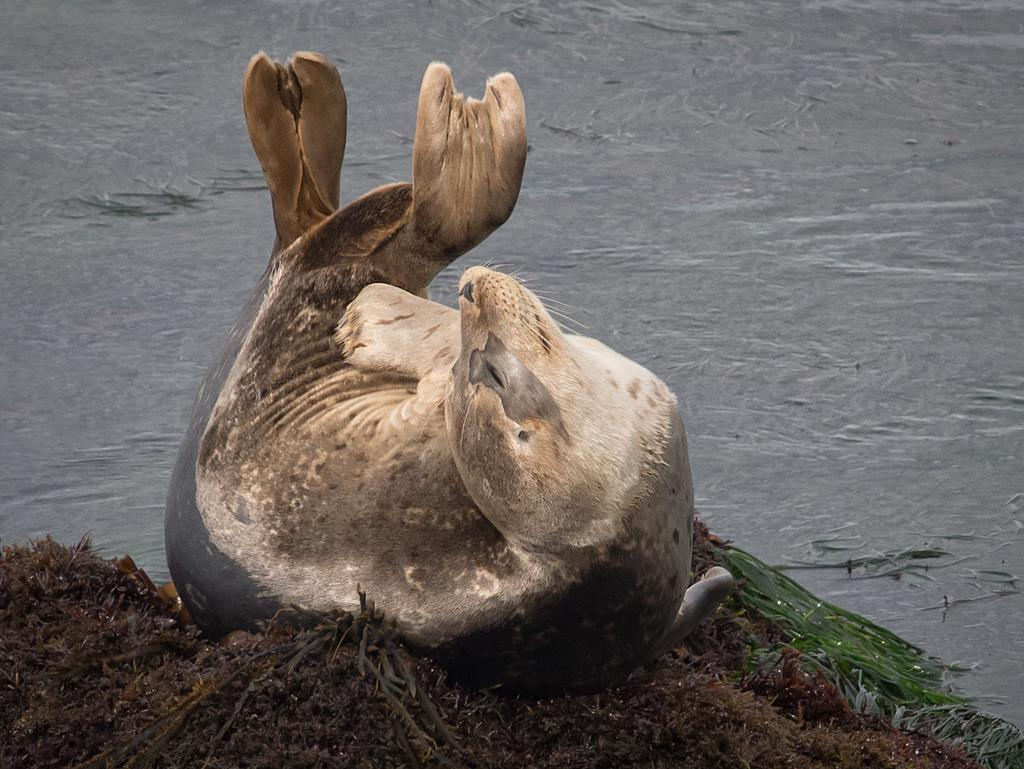What is the main subject in the center of the image? There is an animal in the center of the image. What can be seen in the background of the image? There is water visible in the background of the image. What type of vegetation is at the bottom of the image? There is grass at the bottom of the image. Is there a badge attached to the animal in the image? There is no badge present on the animal in the image. What season is depicted in the image, considering the presence of water and grass? The season cannot be determined from the image, as there are no specific indicators of seasonality. 